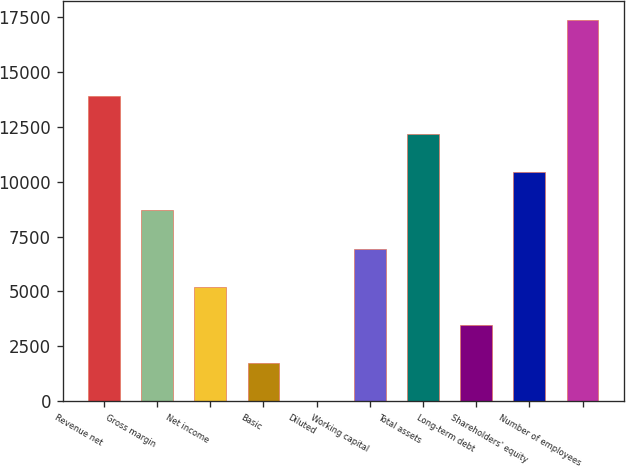Convert chart. <chart><loc_0><loc_0><loc_500><loc_500><bar_chart><fcel>Revenue net<fcel>Gross margin<fcel>Net income<fcel>Basic<fcel>Diluted<fcel>Working capital<fcel>Total assets<fcel>Long-term debt<fcel>Shareholders' equity<fcel>Number of employees<nl><fcel>13900.9<fcel>8688.34<fcel>5213.28<fcel>1738.22<fcel>0.69<fcel>6950.81<fcel>12163.4<fcel>3475.75<fcel>10425.9<fcel>17376<nl></chart> 